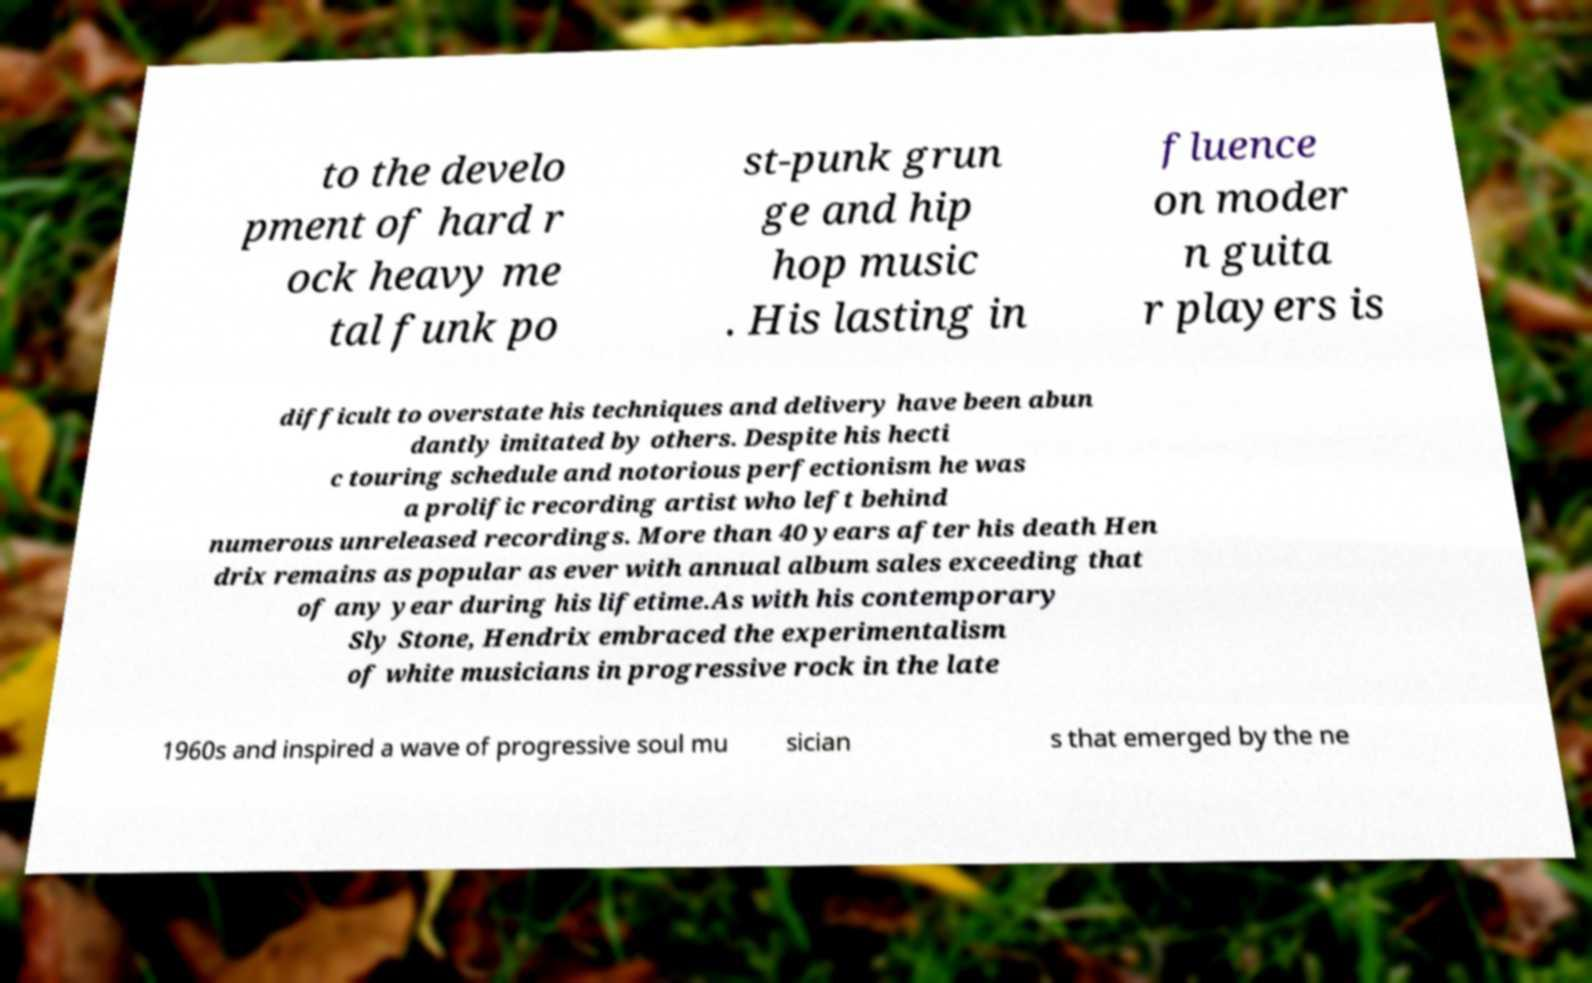There's text embedded in this image that I need extracted. Can you transcribe it verbatim? to the develo pment of hard r ock heavy me tal funk po st-punk grun ge and hip hop music . His lasting in fluence on moder n guita r players is difficult to overstate his techniques and delivery have been abun dantly imitated by others. Despite his hecti c touring schedule and notorious perfectionism he was a prolific recording artist who left behind numerous unreleased recordings. More than 40 years after his death Hen drix remains as popular as ever with annual album sales exceeding that of any year during his lifetime.As with his contemporary Sly Stone, Hendrix embraced the experimentalism of white musicians in progressive rock in the late 1960s and inspired a wave of progressive soul mu sician s that emerged by the ne 